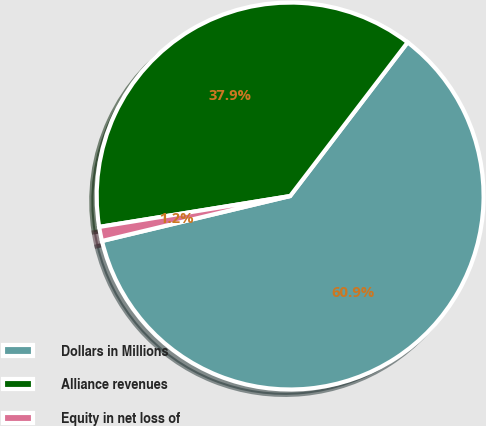Convert chart to OTSL. <chart><loc_0><loc_0><loc_500><loc_500><pie_chart><fcel>Dollars in Millions<fcel>Alliance revenues<fcel>Equity in net loss of<nl><fcel>60.88%<fcel>37.94%<fcel>1.18%<nl></chart> 